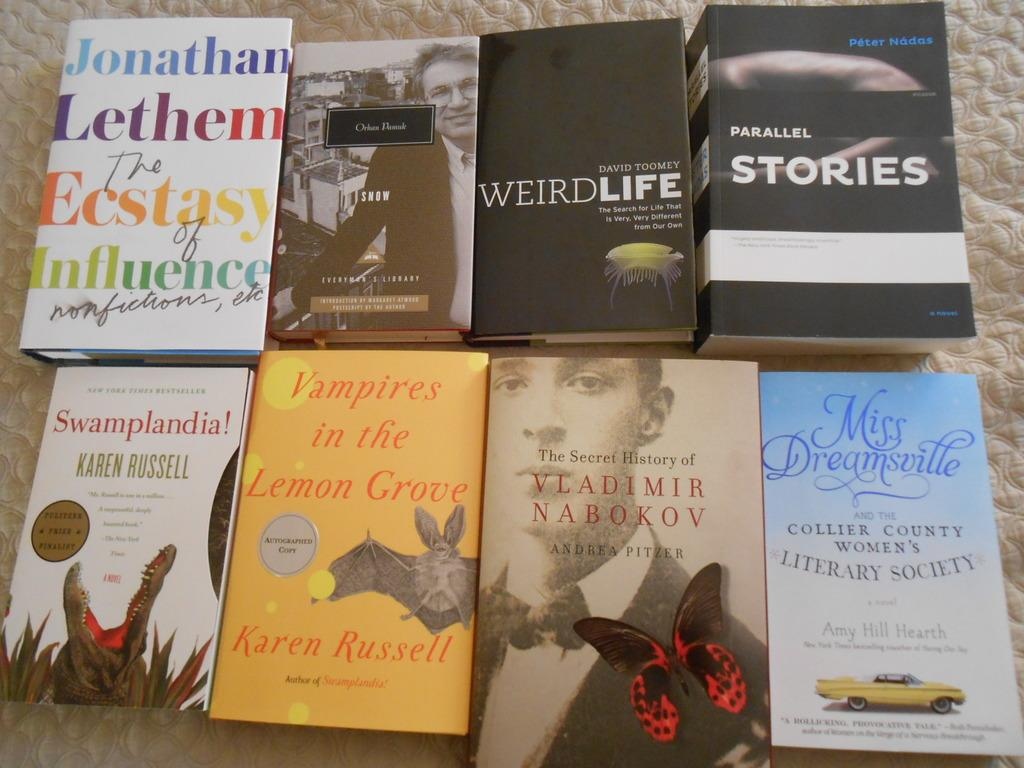<image>
Provide a brief description of the given image. A set of books on a table includes Vampires in the Lemon Grove and Weird Life. 